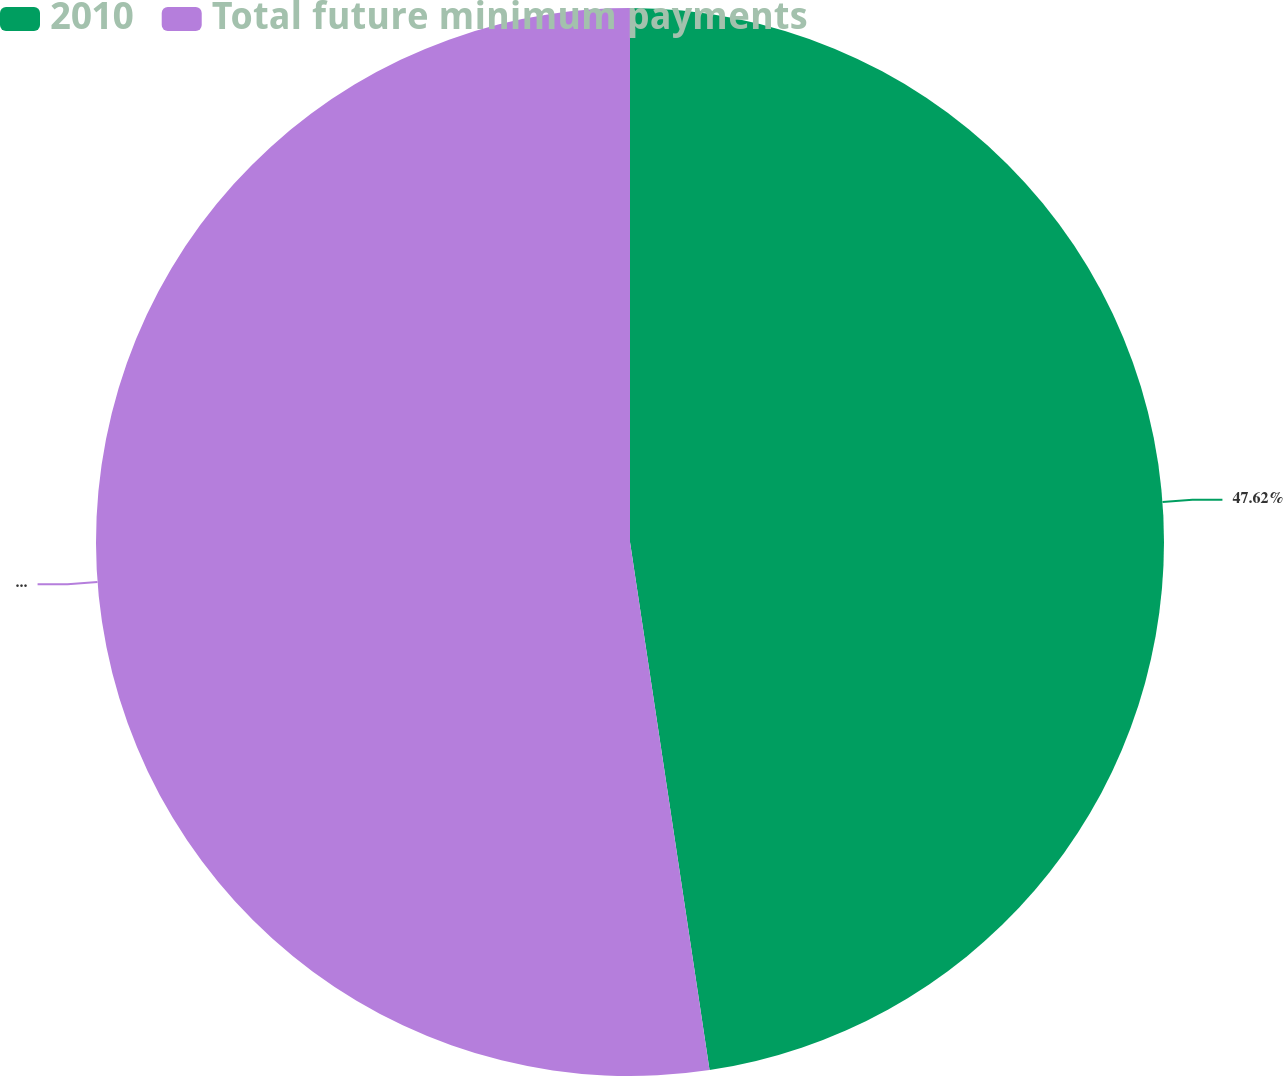Convert chart. <chart><loc_0><loc_0><loc_500><loc_500><pie_chart><fcel>2010<fcel>Total future minimum payments<nl><fcel>47.62%<fcel>52.38%<nl></chart> 